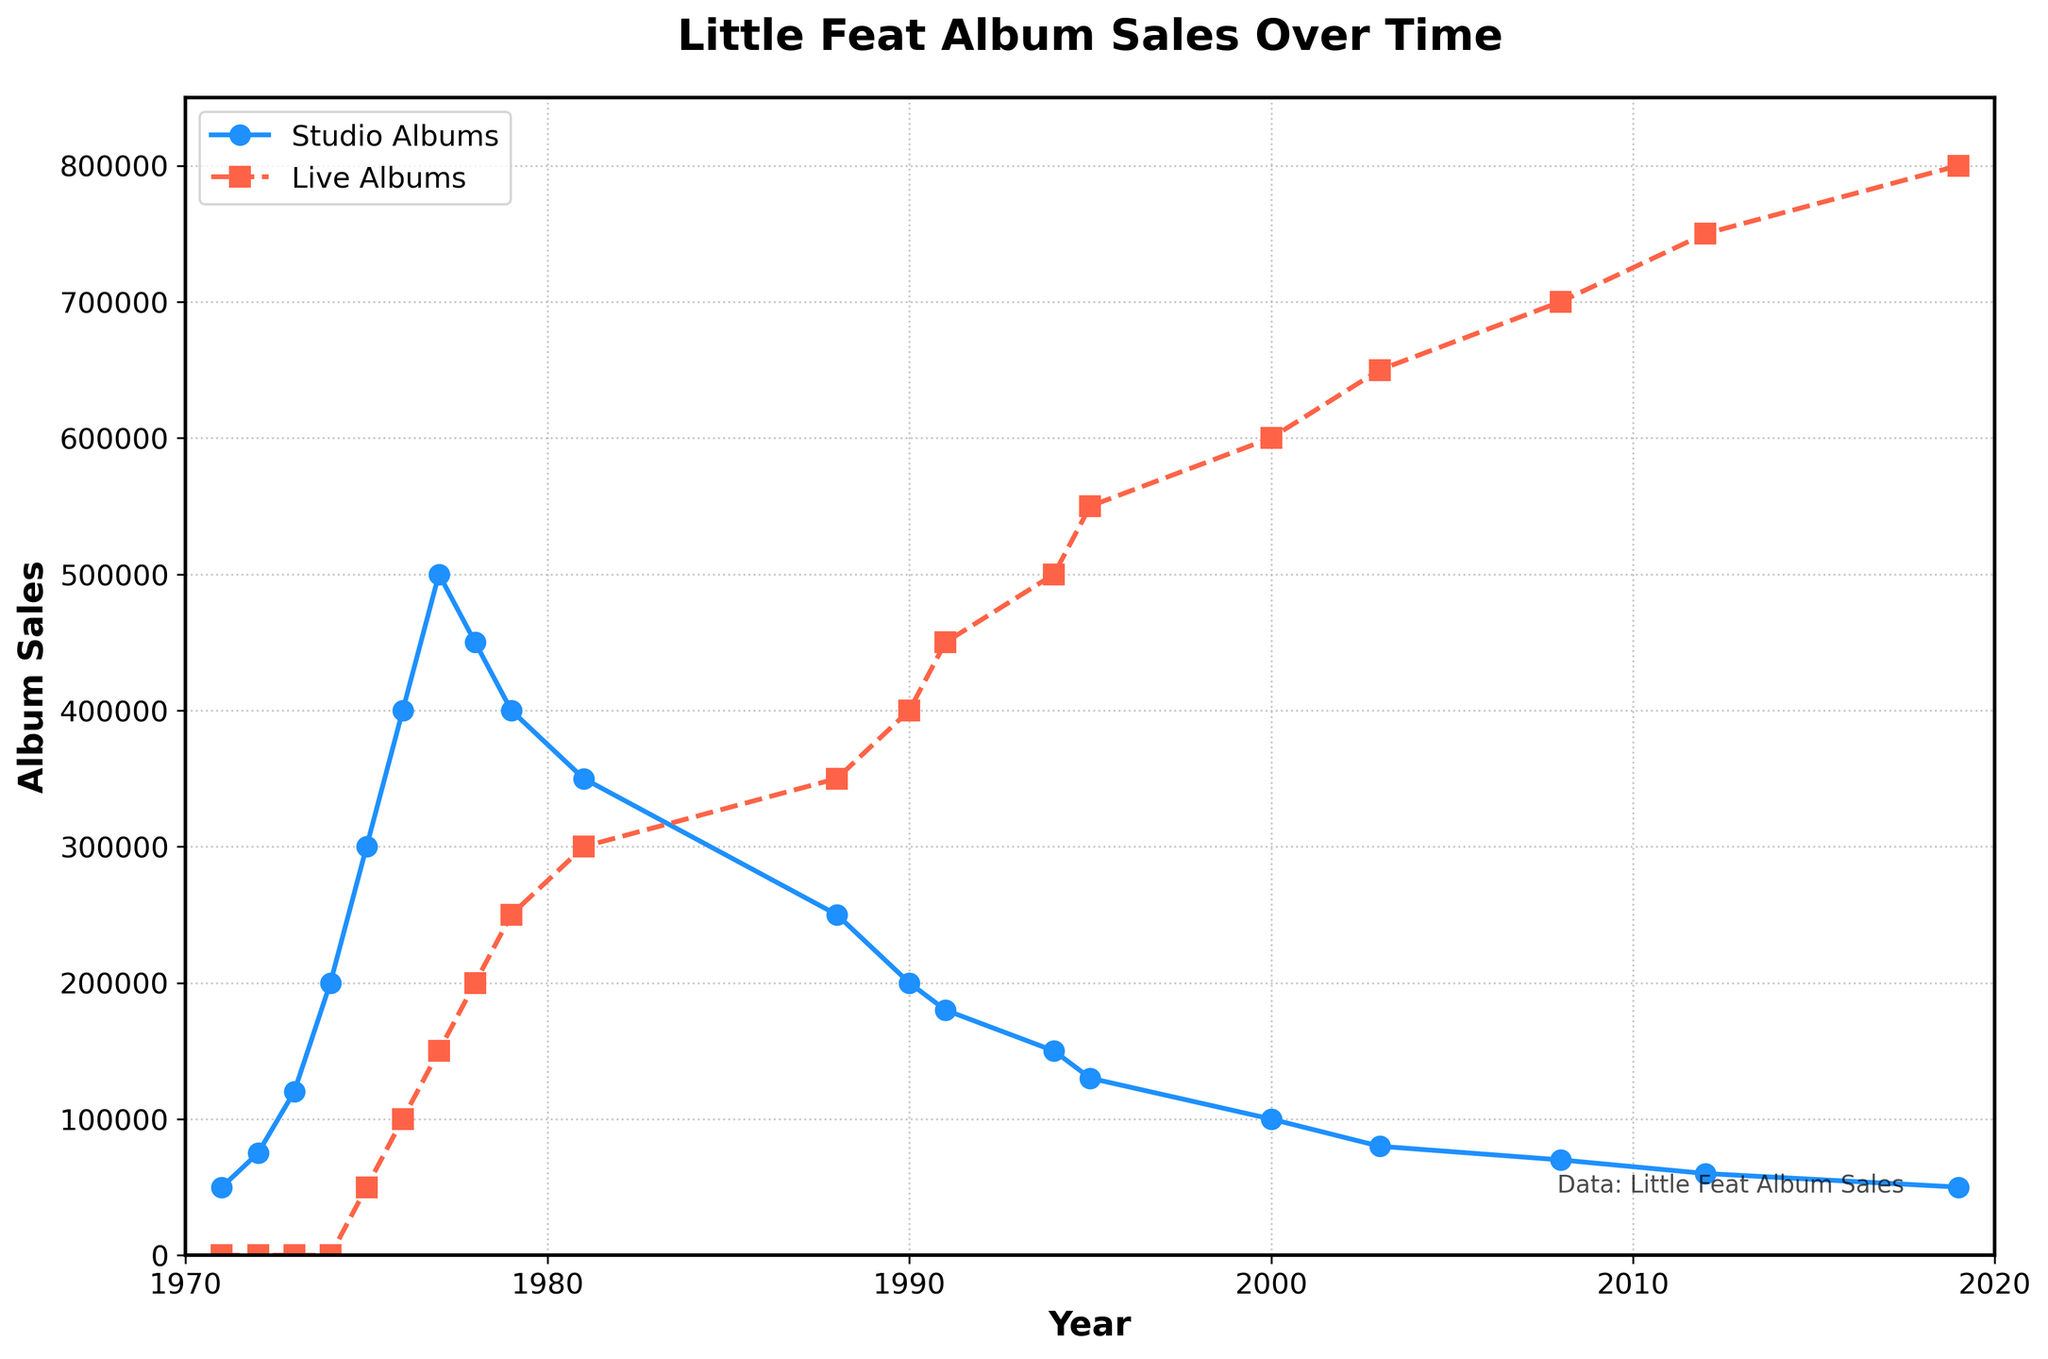What is the peak sales year for studio albums? The peak sales year for studio albums can be found by identifying the year with the highest point on the blue line chart. The highest point for studio album sales occurs in 1977.
Answer: 1977 In which year did live albums surpass studio albums in sales for the first time? To determine this, compare the values of both lines year by year. Live album sales first surpass studio album sales in 1990, where live album sales are 400,000 and studio album sales are 200,000.
Answer: 1990 What is the combined sales of studio and live albums in 1978? To find the combined sales, sum the sales data for both studio and live albums in 1978. Studio album sales are 450,000, and live album sales are 200,000. So, 450,000 + 200,000 = 650,000.
Answer: 650,000 By what percentage did studio album sales decrease from 1977 to 1981? To calculate the percentage decrease, take the difference in studio sales between 1977 and 1981, divide by the 1977 sales, and multiply by 100. The sales in 1977 were 500,000, and in 1981 were 350,000. The difference is 150,000. So, (150,000 / 500,000) * 100 = 30%.
Answer: 30% Which year shows the closest sales figures between studio albums and live albums, and what are the amounts? To determine the year with the closest sales, compute the difference between studio and live album sales for each year. In 1976, studio album sales were 400,000, and live album sales were 100,000, a difference of 300,000. In 2000, studio album sales were 100,000, and live album sales were 600,000, a difference of 500,000. Continue until finding the smallest difference, which is in 1974-1975. The closest values are in the year 1975, with studio album sales at 300,000 and live album sales at 50,000, a difference of 50,000.
Answer: 1975, Studio: 300,000, Live: 50,000 Select the sequence in which live album sales outweigh studio album sales from the largest to the smallest difference between the two. Calculate the absolute difference between studio and live album sales for each given year, then sort the sequence based on descending order of those differences. For instance, in 2019, live album sales exceed studio album sales by 750,000 (800,000 - 50,000), the highest difference. Another large difference is in 2003, where live album sales are 650,000 more than studio albums (650,000 - 80,000). Construct the sequence based on this approach.
Answer: 2019, 2012, 2008, 2003, and so on 